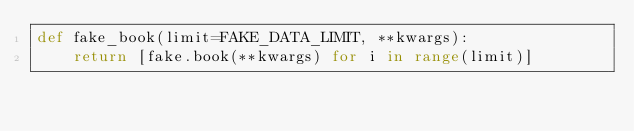Convert code to text. <code><loc_0><loc_0><loc_500><loc_500><_Python_>def fake_book(limit=FAKE_DATA_LIMIT, **kwargs):
    return [fake.book(**kwargs) for i in range(limit)]
</code> 